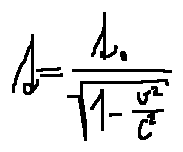Convert formula to latex. <formula><loc_0><loc_0><loc_500><loc_500>t = \frac { t _ { 0 } } { \sqrt { 1 - \frac { v ^ { 2 } } { c ^ { 2 } } } }</formula> 